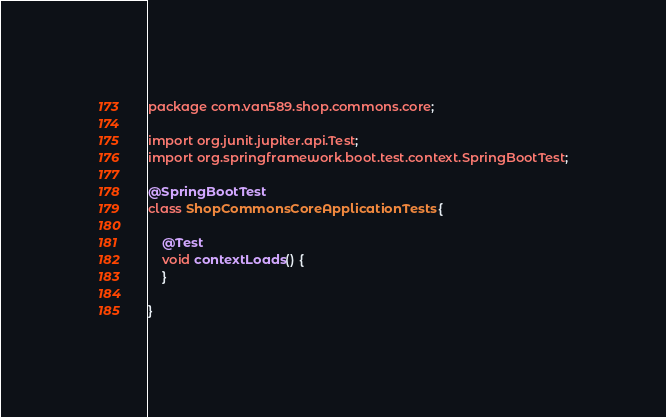<code> <loc_0><loc_0><loc_500><loc_500><_Java_>package com.van589.shop.commons.core;

import org.junit.jupiter.api.Test;
import org.springframework.boot.test.context.SpringBootTest;

@SpringBootTest
class ShopCommonsCoreApplicationTests {

    @Test
    void contextLoads() {
    }

}
</code> 